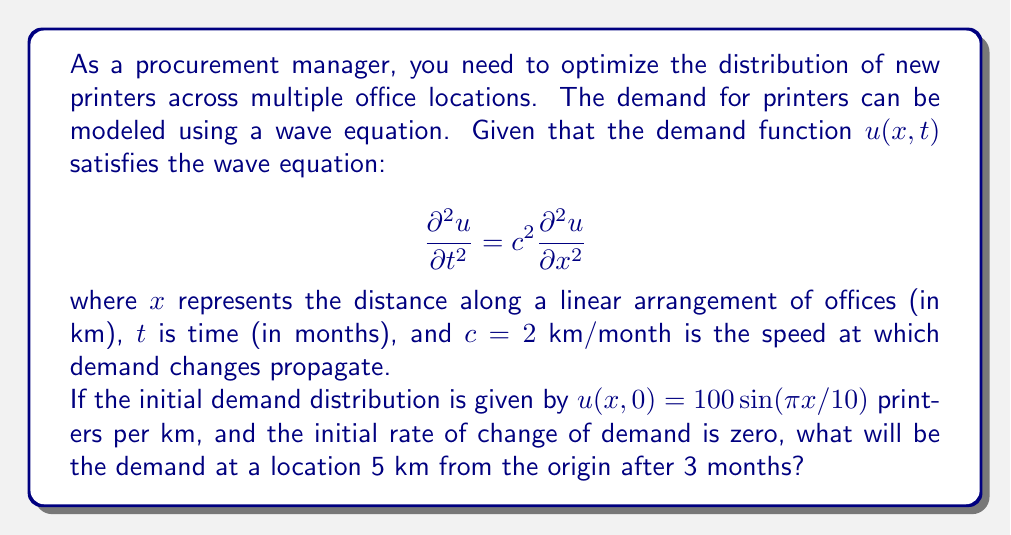Can you solve this math problem? To solve this problem, we need to use the general solution of the wave equation with the given initial conditions. The steps are as follows:

1) The general solution of the wave equation is given by D'Alembert's formula:

   $$u(x,t) = f(x-ct) + g(x+ct)$$

   where $f$ and $g$ are determined by the initial conditions.

2) Given the initial conditions:
   
   $u(x,0) = 100 \sin(\pi x/10)$
   $\frac{\partial u}{\partial t}(x,0) = 0$

3) From the first condition:

   $f(x) + g(x) = 100 \sin(\pi x/10)$

4) From the second condition:

   $-cf'(x) + cg'(x) = 0$

   This implies $f'(x) = g'(x)$, so $f(x) = g(x) + \text{constant}$

5) Combining these results:

   $2f(x) = 100 \sin(\pi x/10)$
   $f(x) = 50 \sin(\pi x/10)$
   $g(x) = 50 \sin(\pi x/10)$

6) Therefore, the solution is:

   $$u(x,t) = 50 \sin[\pi(x-ct)/10] + 50 \sin[\pi(x+ct)/10]$$

7) Now, we need to evaluate this at $x=5$ km, $t=3$ months, and $c=2$ km/month:

   $$u(5,3) = 50 \sin[\pi(5-2*3)/10] + 50 \sin[\pi(5+2*3)/10]$$
   $$= 50 \sin[-\pi/10] + 50 \sin[11\pi/10]$$
   $$= -50 \sin[\pi/10] + 50 \sin[\pi/10]$$
   $$= 0$$

8) Therefore, the demand at a location 5 km from the origin after 3 months will be 0 printers per km.
Answer: 0 printers per km 